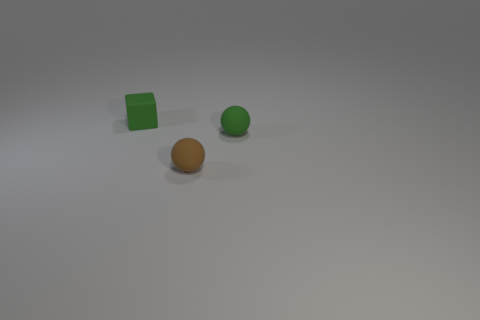What color is the tiny sphere behind the brown rubber ball?
Provide a short and direct response. Green. What material is the tiny ball left of the small green object in front of the matte block?
Your answer should be compact. Rubber. What shape is the brown object?
Offer a terse response. Sphere. How many green objects are the same size as the green cube?
Ensure brevity in your answer.  1. There is a green object in front of the green cube; is there a small object that is to the left of it?
Your answer should be very brief. Yes. What number of brown objects are matte things or big objects?
Offer a terse response. 1. What color is the tiny matte cube?
Give a very brief answer. Green. There is a brown thing that is made of the same material as the green cube; what is its size?
Offer a very short reply. Small. How many small green objects have the same shape as the brown thing?
Your response must be concise. 1. There is a object that is in front of the tiny green object that is in front of the small green cube; how big is it?
Make the answer very short. Small. 